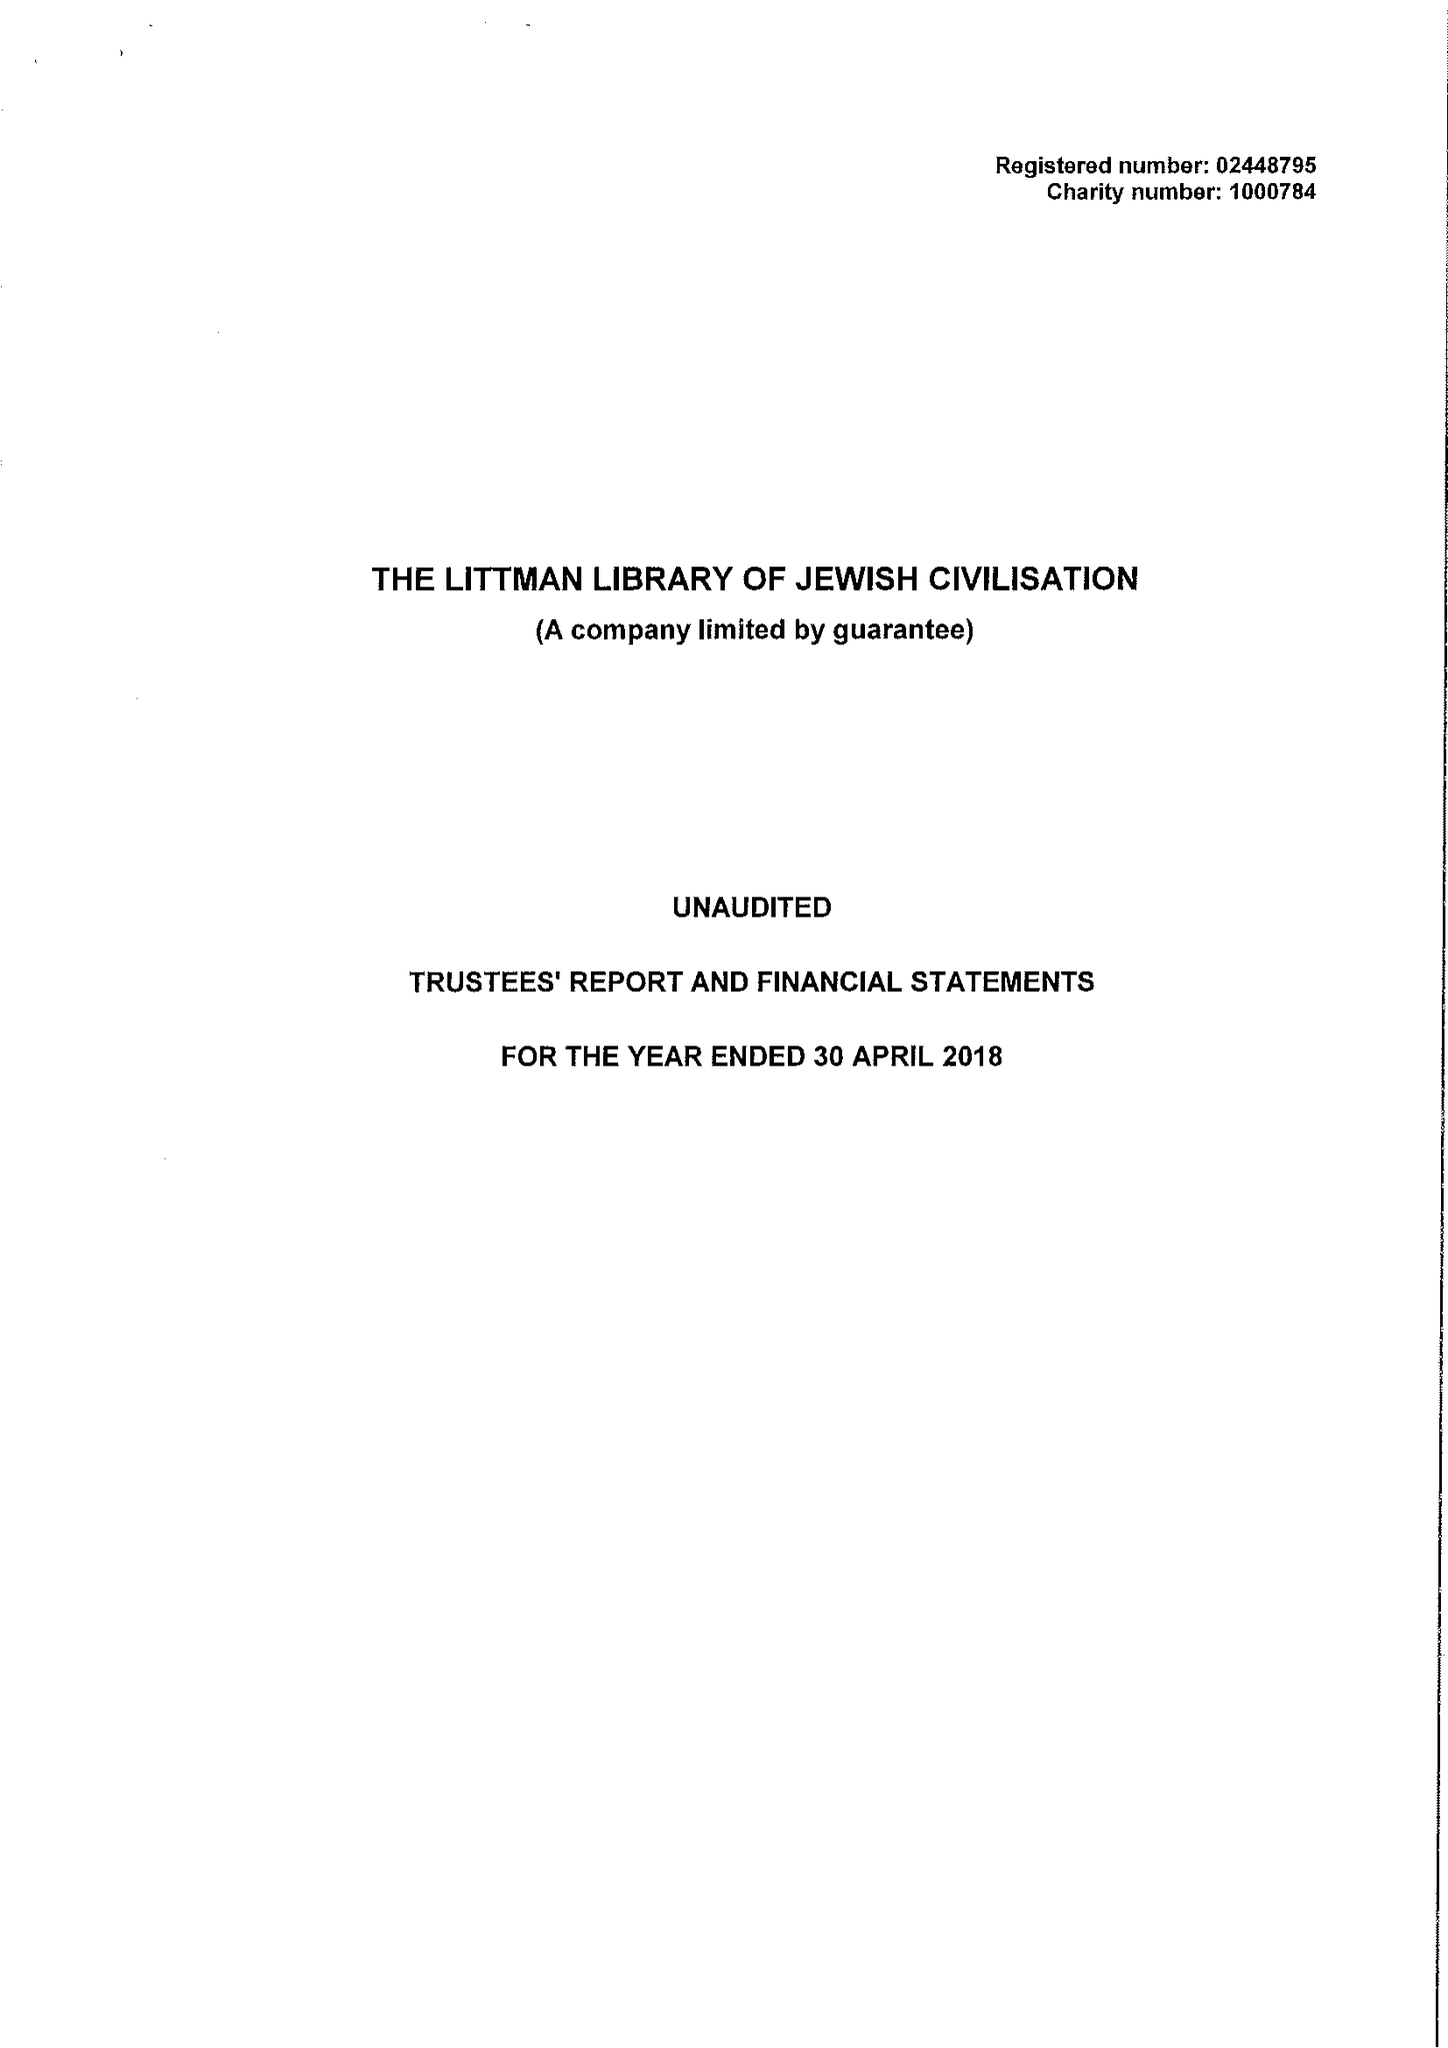What is the value for the charity_number?
Answer the question using a single word or phrase. 1000784 